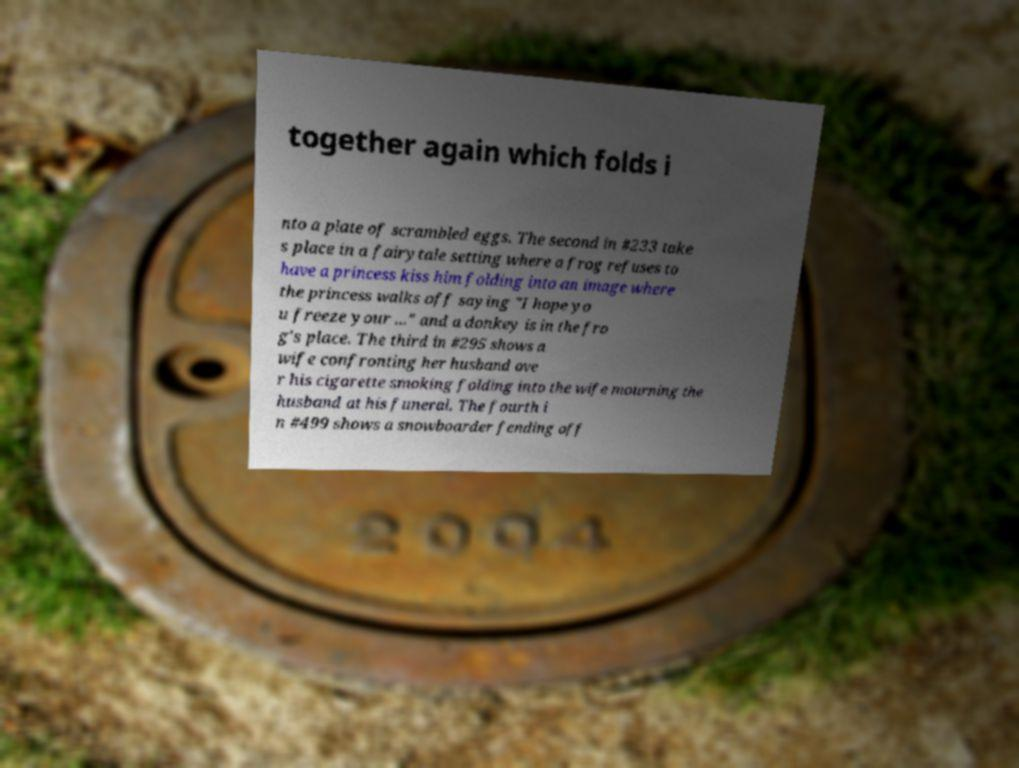What messages or text are displayed in this image? I need them in a readable, typed format. together again which folds i nto a plate of scrambled eggs. The second in #233 take s place in a fairytale setting where a frog refuses to have a princess kiss him folding into an image where the princess walks off saying "I hope yo u freeze your ..." and a donkey is in the fro g's place. The third in #295 shows a wife confronting her husband ove r his cigarette smoking folding into the wife mourning the husband at his funeral. The fourth i n #499 shows a snowboarder fending off 